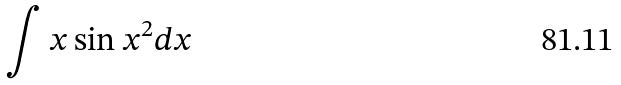<formula> <loc_0><loc_0><loc_500><loc_500>\int x \sin x ^ { 2 } d x</formula> 